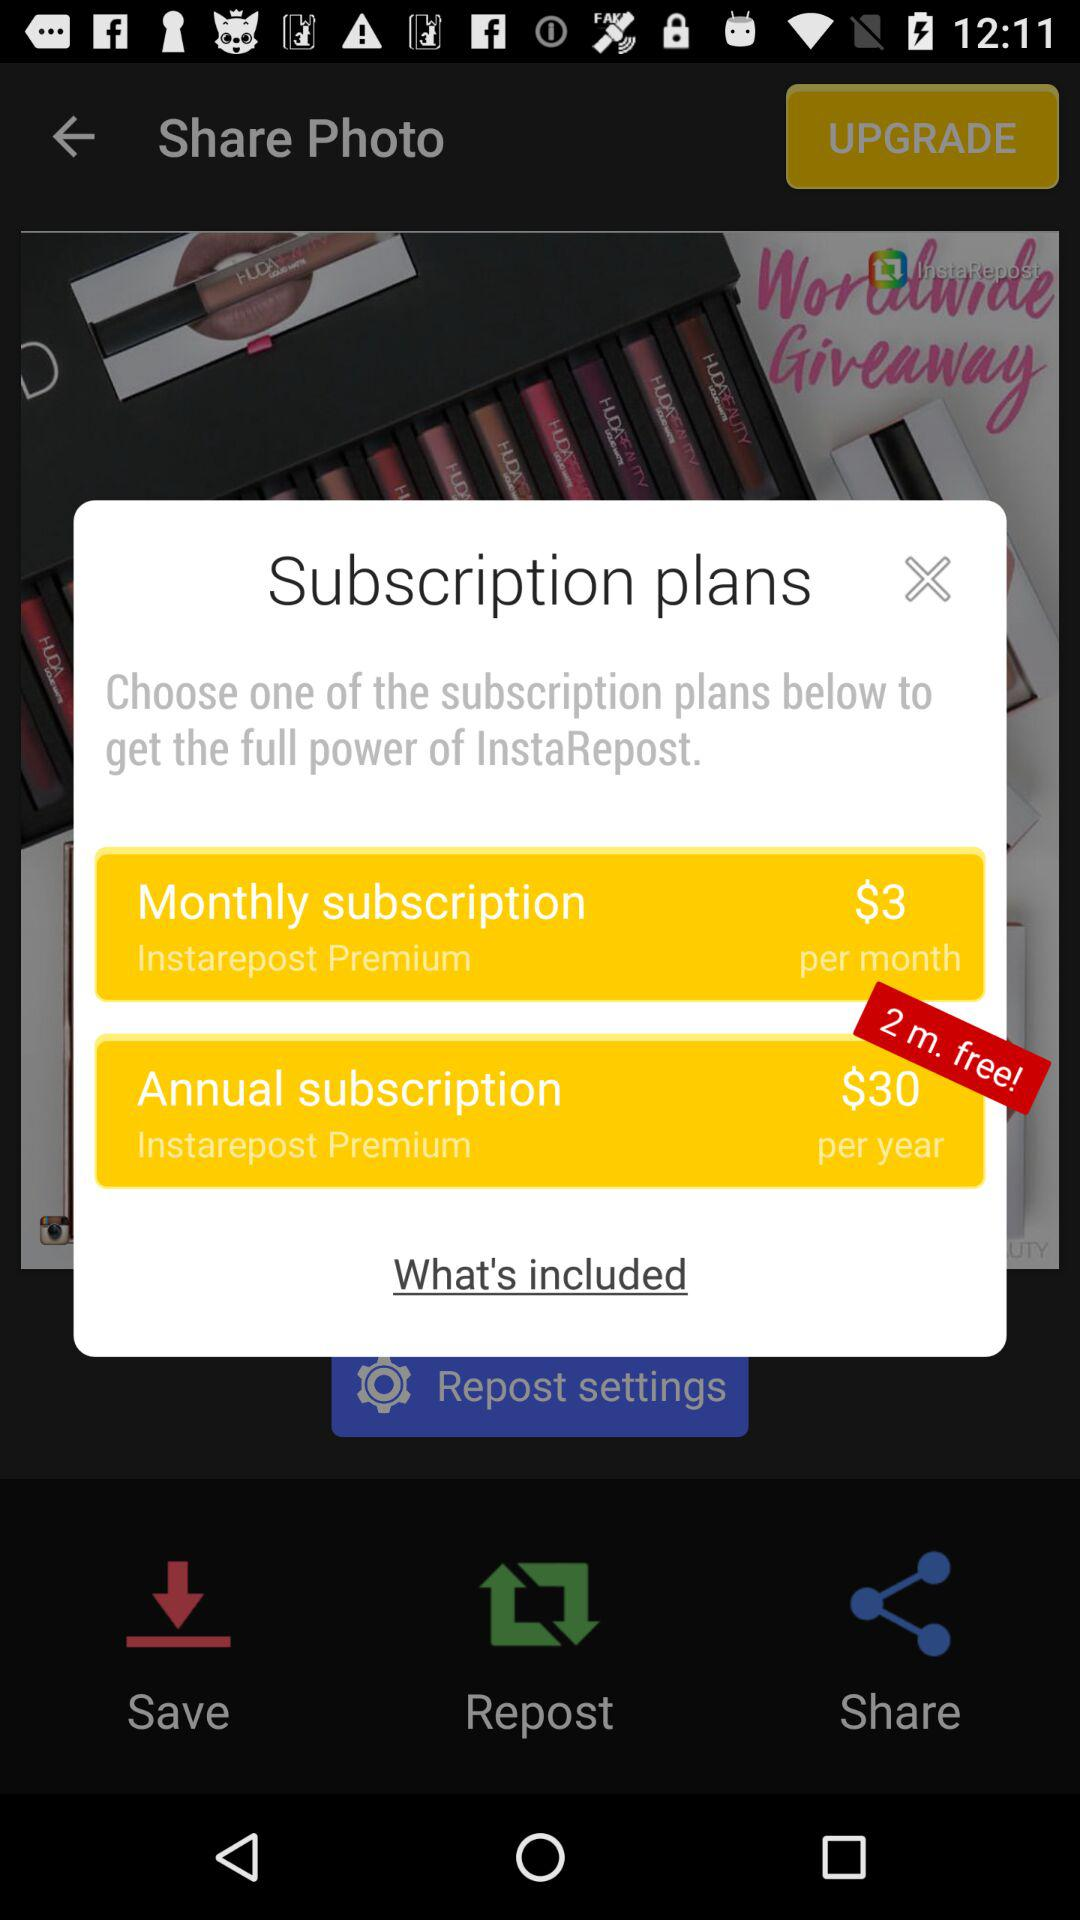What is the monthly subscription charge? The monthly subscription charge is $3. 